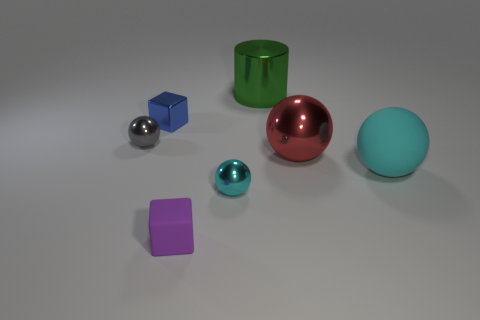Subtract all large shiny balls. How many balls are left? 3 Add 2 matte blocks. How many objects exist? 9 Subtract all blocks. How many objects are left? 5 Subtract all cyan balls. How many balls are left? 2 Subtract all gray balls. Subtract all yellow blocks. How many balls are left? 3 Subtract all cyan balls. How many blue cubes are left? 1 Subtract all large shiny things. Subtract all large cyan shiny spheres. How many objects are left? 5 Add 4 red metallic spheres. How many red metallic spheres are left? 5 Add 3 cyan spheres. How many cyan spheres exist? 5 Subtract 1 blue cubes. How many objects are left? 6 